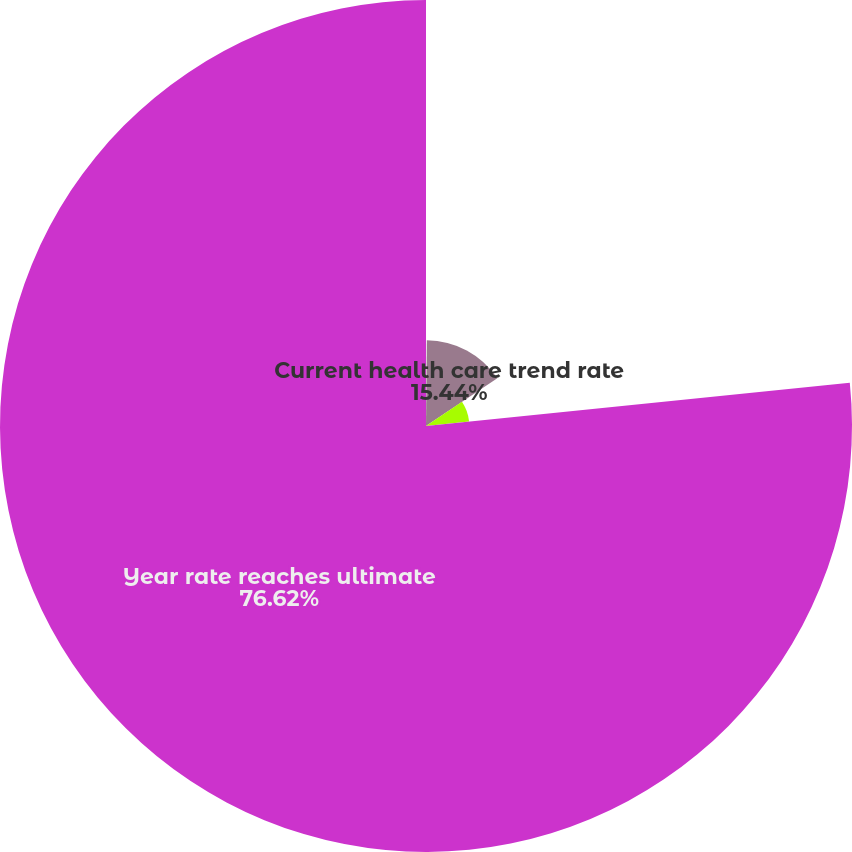<chart> <loc_0><loc_0><loc_500><loc_500><pie_chart><fcel>Discount rate<fcel>Current health care trend rate<fcel>Ultimate health care trend<fcel>Year rate reaches ultimate<nl><fcel>0.15%<fcel>15.44%<fcel>7.79%<fcel>76.62%<nl></chart> 